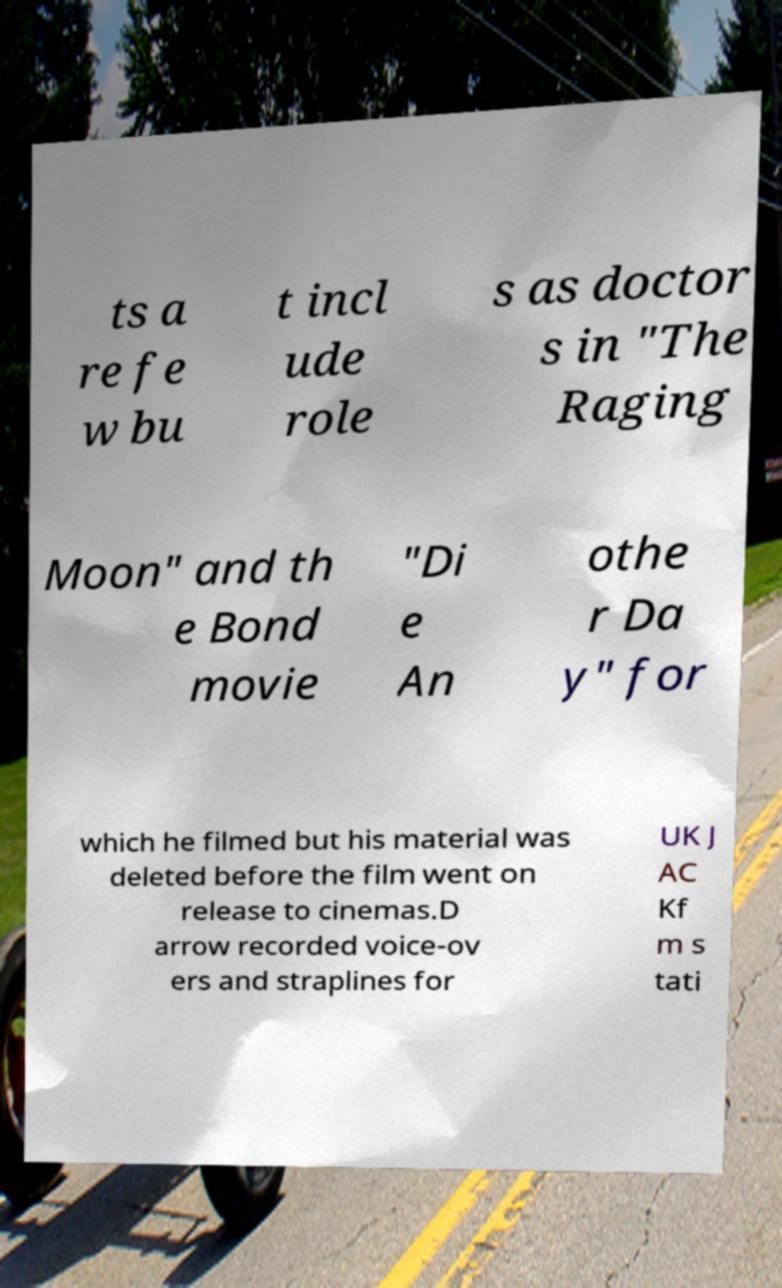Please identify and transcribe the text found in this image. ts a re fe w bu t incl ude role s as doctor s in "The Raging Moon" and th e Bond movie "Di e An othe r Da y" for which he filmed but his material was deleted before the film went on release to cinemas.D arrow recorded voice-ov ers and straplines for UK J AC Kf m s tati 